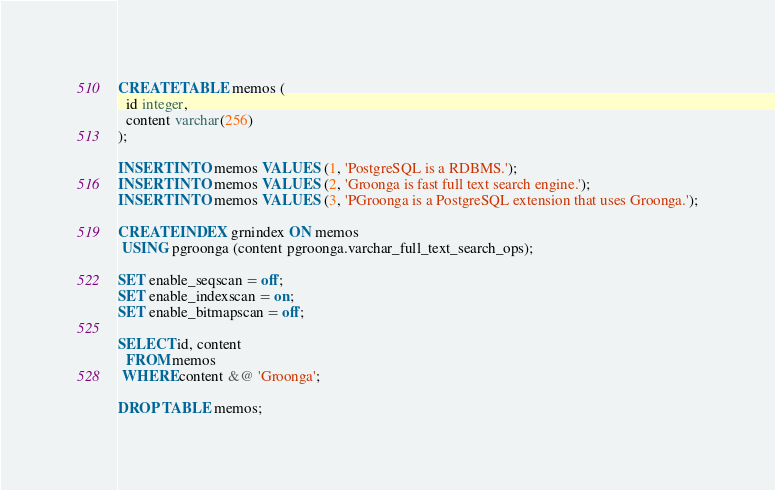Convert code to text. <code><loc_0><loc_0><loc_500><loc_500><_SQL_>CREATE TABLE memos (
  id integer,
  content varchar(256)
);

INSERT INTO memos VALUES (1, 'PostgreSQL is a RDBMS.');
INSERT INTO memos VALUES (2, 'Groonga is fast full text search engine.');
INSERT INTO memos VALUES (3, 'PGroonga is a PostgreSQL extension that uses Groonga.');

CREATE INDEX grnindex ON memos
 USING pgroonga (content pgroonga.varchar_full_text_search_ops);

SET enable_seqscan = off;
SET enable_indexscan = on;
SET enable_bitmapscan = off;

SELECT id, content
  FROM memos
 WHERE content &@ 'Groonga';

DROP TABLE memos;
</code> 